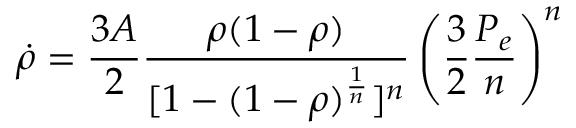Convert formula to latex. <formula><loc_0><loc_0><loc_500><loc_500>{ \dot { \rho } } = { \frac { 3 A } { 2 } } { \frac { \rho ( 1 - \rho ) } { [ 1 - ( 1 - \rho ) ^ { \frac { 1 } { n } } ] ^ { n } } } \left ( { \frac { 3 } { 2 } } { \frac { P _ { e } } { n } } \right ) ^ { n }</formula> 